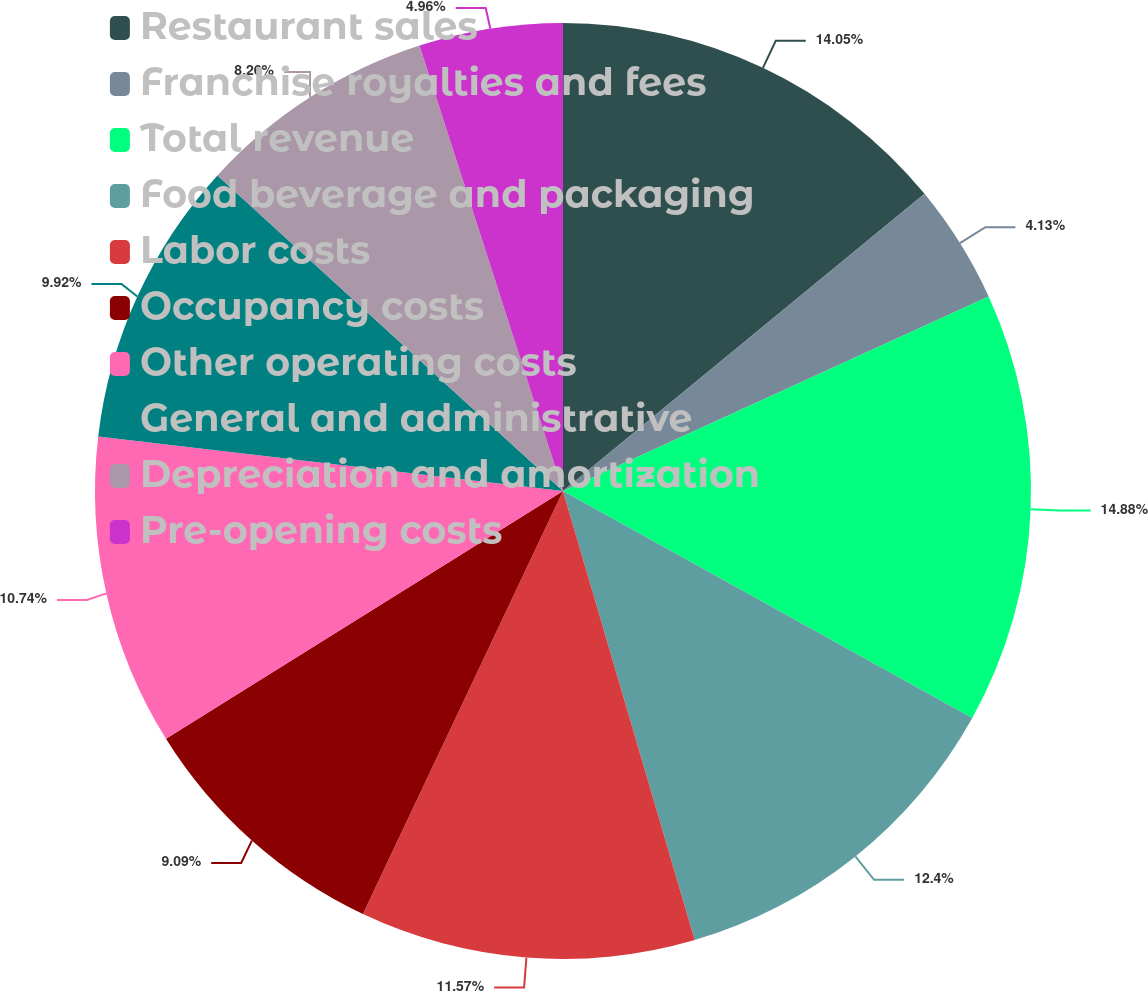Convert chart. <chart><loc_0><loc_0><loc_500><loc_500><pie_chart><fcel>Restaurant sales<fcel>Franchise royalties and fees<fcel>Total revenue<fcel>Food beverage and packaging<fcel>Labor costs<fcel>Occupancy costs<fcel>Other operating costs<fcel>General and administrative<fcel>Depreciation and amortization<fcel>Pre-opening costs<nl><fcel>14.05%<fcel>4.13%<fcel>14.88%<fcel>12.4%<fcel>11.57%<fcel>9.09%<fcel>10.74%<fcel>9.92%<fcel>8.26%<fcel>4.96%<nl></chart> 